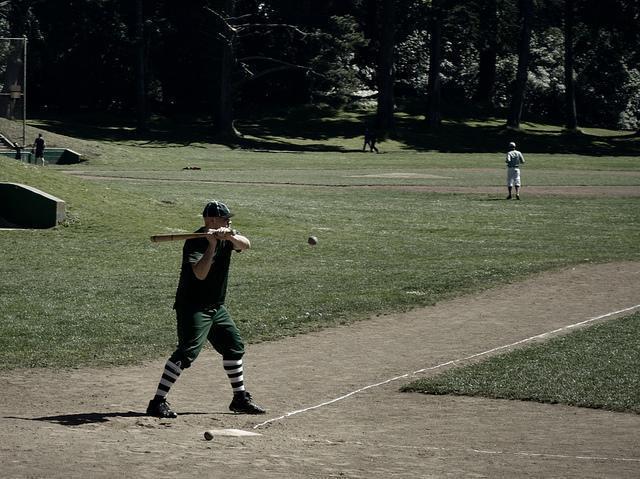How many players are in the photo?
Give a very brief answer. 2. 